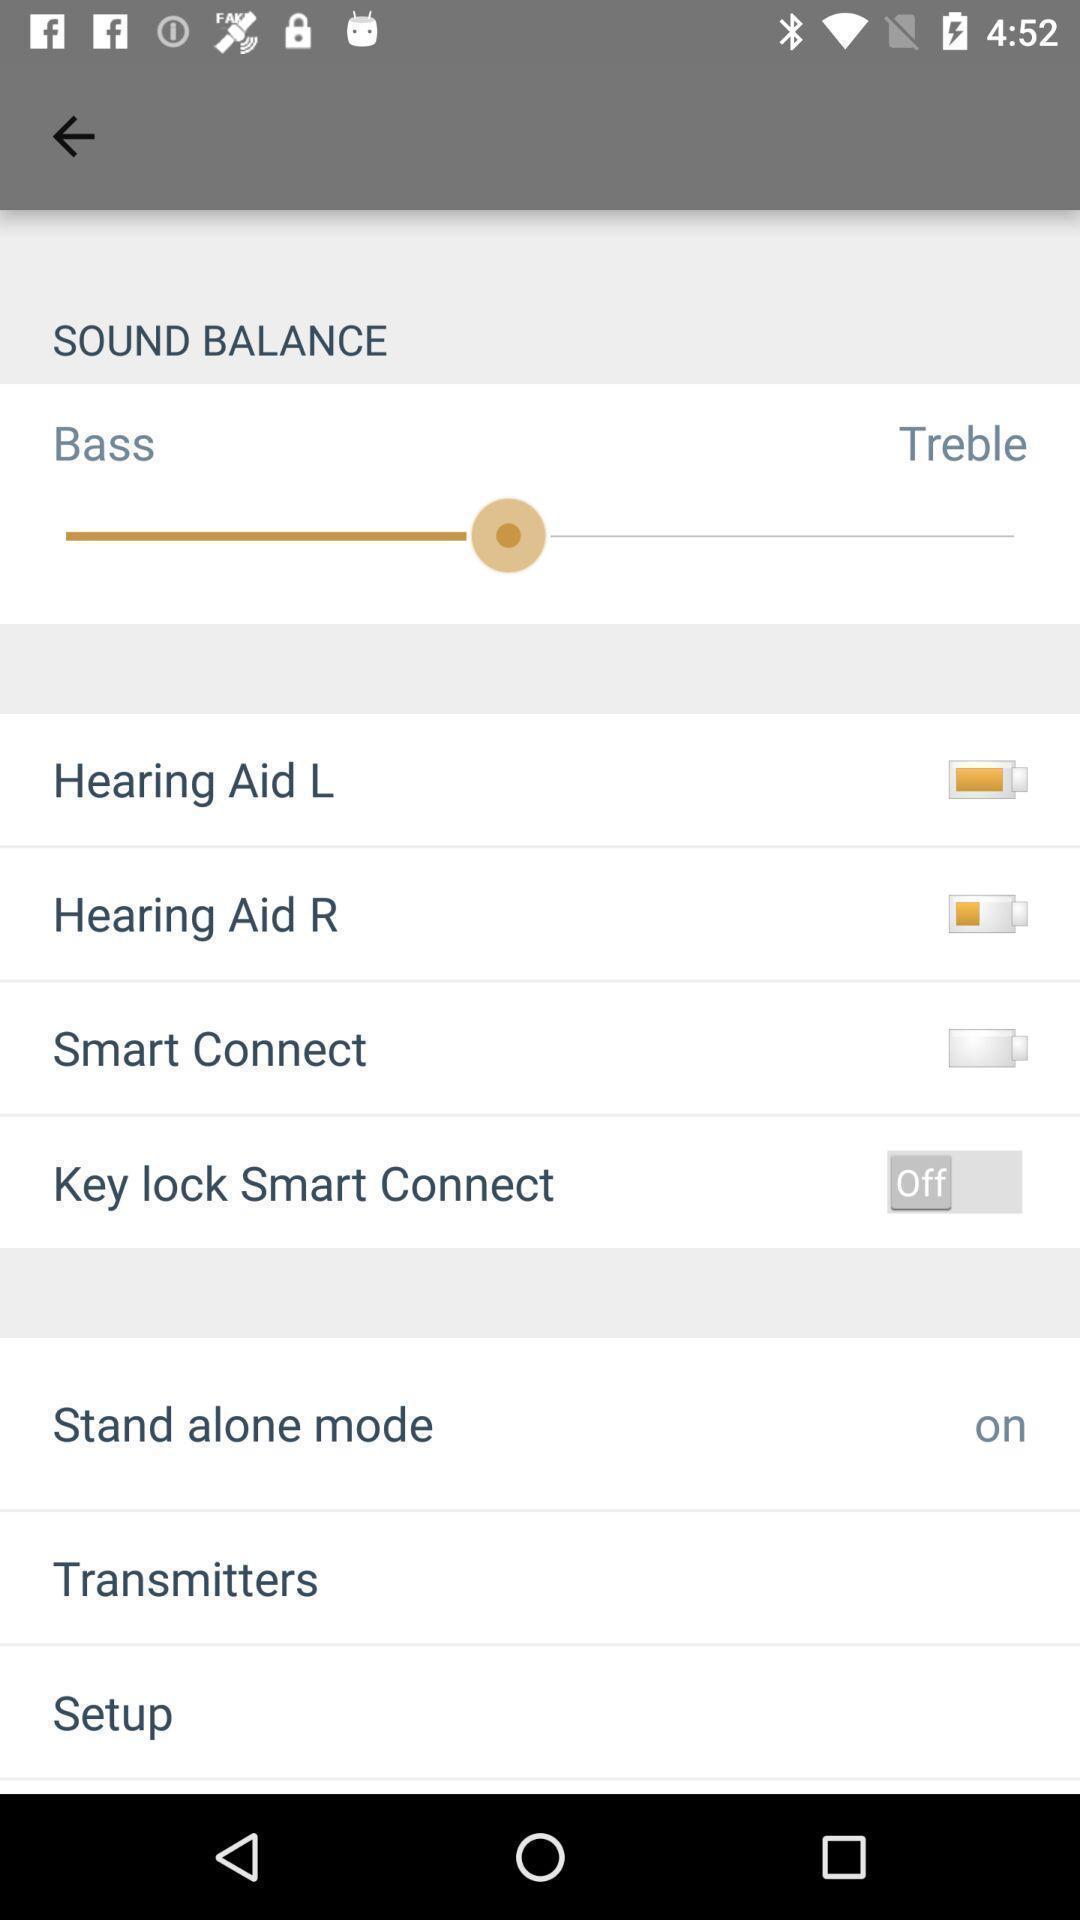Describe this image in words. Various preferences and options displayed of a hearing aid app. 